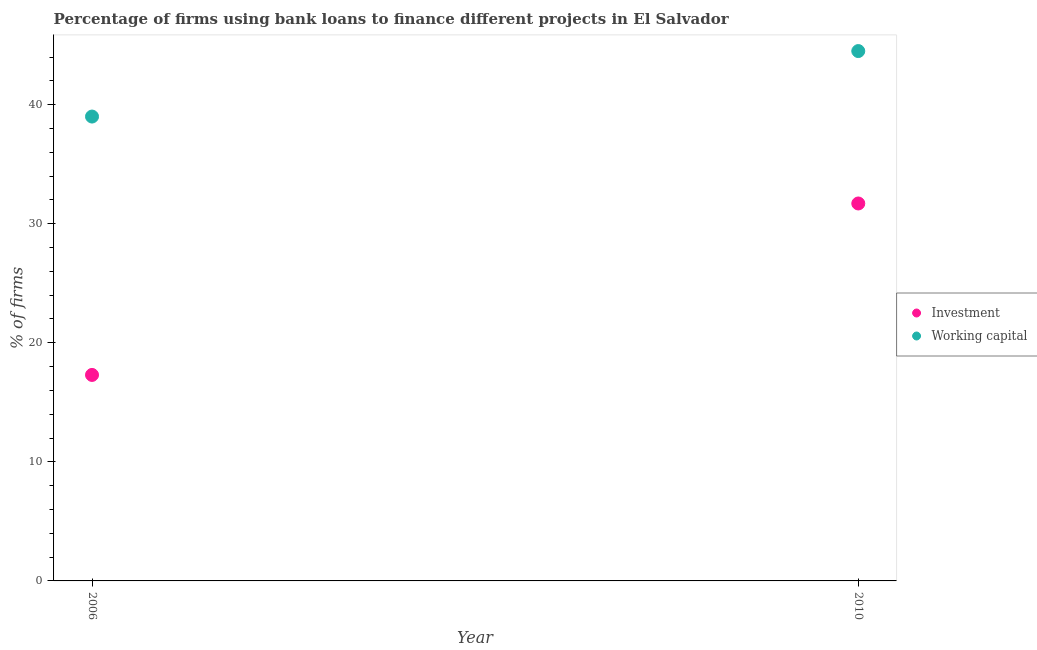How many different coloured dotlines are there?
Provide a succinct answer. 2. Is the number of dotlines equal to the number of legend labels?
Give a very brief answer. Yes. What is the percentage of firms using banks to finance working capital in 2006?
Offer a very short reply. 39. Across all years, what is the maximum percentage of firms using banks to finance working capital?
Your response must be concise. 44.5. Across all years, what is the minimum percentage of firms using banks to finance working capital?
Keep it short and to the point. 39. In which year was the percentage of firms using banks to finance investment maximum?
Provide a short and direct response. 2010. In which year was the percentage of firms using banks to finance working capital minimum?
Your response must be concise. 2006. What is the total percentage of firms using banks to finance investment in the graph?
Ensure brevity in your answer.  49. What is the difference between the percentage of firms using banks to finance investment in 2006 and that in 2010?
Make the answer very short. -14.4. What is the difference between the percentage of firms using banks to finance working capital in 2010 and the percentage of firms using banks to finance investment in 2006?
Ensure brevity in your answer.  27.2. What is the average percentage of firms using banks to finance working capital per year?
Ensure brevity in your answer.  41.75. In the year 2006, what is the difference between the percentage of firms using banks to finance working capital and percentage of firms using banks to finance investment?
Keep it short and to the point. 21.7. In how many years, is the percentage of firms using banks to finance working capital greater than 6 %?
Provide a short and direct response. 2. What is the ratio of the percentage of firms using banks to finance investment in 2006 to that in 2010?
Give a very brief answer. 0.55. In how many years, is the percentage of firms using banks to finance working capital greater than the average percentage of firms using banks to finance working capital taken over all years?
Give a very brief answer. 1. Does the percentage of firms using banks to finance investment monotonically increase over the years?
Make the answer very short. Yes. Is the percentage of firms using banks to finance working capital strictly less than the percentage of firms using banks to finance investment over the years?
Make the answer very short. No. Does the graph contain any zero values?
Make the answer very short. No. Where does the legend appear in the graph?
Offer a very short reply. Center right. How many legend labels are there?
Offer a terse response. 2. How are the legend labels stacked?
Provide a succinct answer. Vertical. What is the title of the graph?
Your answer should be very brief. Percentage of firms using bank loans to finance different projects in El Salvador. Does "Foreign liabilities" appear as one of the legend labels in the graph?
Your answer should be very brief. No. What is the label or title of the X-axis?
Make the answer very short. Year. What is the label or title of the Y-axis?
Offer a terse response. % of firms. What is the % of firms of Investment in 2006?
Your answer should be very brief. 17.3. What is the % of firms in Working capital in 2006?
Give a very brief answer. 39. What is the % of firms of Investment in 2010?
Your answer should be compact. 31.7. What is the % of firms in Working capital in 2010?
Give a very brief answer. 44.5. Across all years, what is the maximum % of firms in Investment?
Your answer should be compact. 31.7. Across all years, what is the maximum % of firms of Working capital?
Your response must be concise. 44.5. Across all years, what is the minimum % of firms of Investment?
Your response must be concise. 17.3. What is the total % of firms of Investment in the graph?
Keep it short and to the point. 49. What is the total % of firms of Working capital in the graph?
Offer a very short reply. 83.5. What is the difference between the % of firms in Investment in 2006 and that in 2010?
Give a very brief answer. -14.4. What is the difference between the % of firms of Working capital in 2006 and that in 2010?
Provide a short and direct response. -5.5. What is the difference between the % of firms in Investment in 2006 and the % of firms in Working capital in 2010?
Make the answer very short. -27.2. What is the average % of firms of Working capital per year?
Ensure brevity in your answer.  41.75. In the year 2006, what is the difference between the % of firms in Investment and % of firms in Working capital?
Your answer should be very brief. -21.7. In the year 2010, what is the difference between the % of firms in Investment and % of firms in Working capital?
Your response must be concise. -12.8. What is the ratio of the % of firms of Investment in 2006 to that in 2010?
Provide a succinct answer. 0.55. What is the ratio of the % of firms in Working capital in 2006 to that in 2010?
Offer a terse response. 0.88. What is the difference between the highest and the second highest % of firms in Investment?
Your answer should be compact. 14.4. What is the difference between the highest and the second highest % of firms in Working capital?
Your answer should be compact. 5.5. What is the difference between the highest and the lowest % of firms of Investment?
Offer a very short reply. 14.4. What is the difference between the highest and the lowest % of firms of Working capital?
Provide a short and direct response. 5.5. 